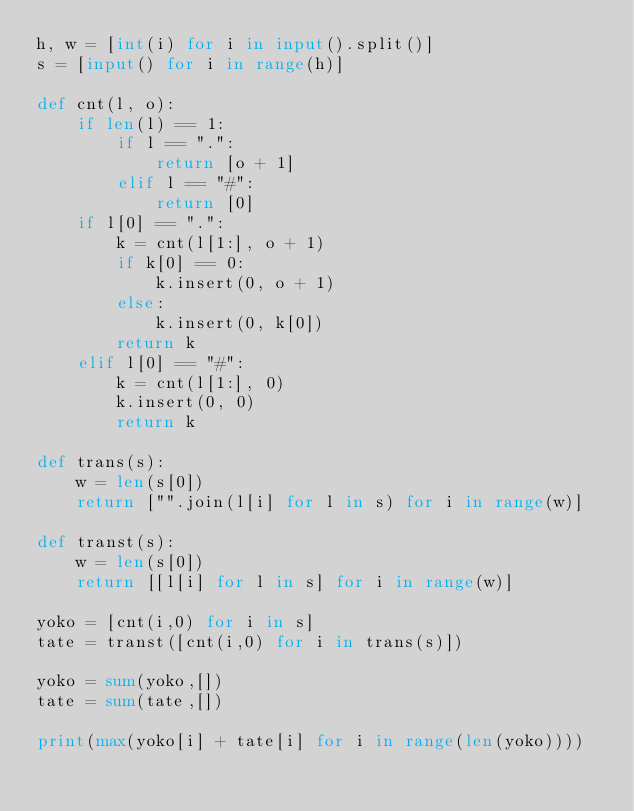Convert code to text. <code><loc_0><loc_0><loc_500><loc_500><_Python_>h, w = [int(i) for i in input().split()]
s = [input() for i in range(h)]

def cnt(l, o):
	if len(l) == 1:
		if l == ".":
			return [o + 1]
		elif l == "#":
			return [0]
	if l[0] == ".":
		k = cnt(l[1:], o + 1)
		if k[0] == 0:
			k.insert(0, o + 1)
		else:
			k.insert(0, k[0])
		return k
	elif l[0] == "#":
		k = cnt(l[1:], 0)
		k.insert(0, 0)
		return k

def trans(s):
	w = len(s[0])
	return ["".join(l[i] for l in s) for i in range(w)]
	
def transt(s):
	w = len(s[0])
	return [[l[i] for l in s] for i in range(w)]
			
yoko = [cnt(i,0) for i in s]
tate = transt([cnt(i,0) for i in trans(s)])

yoko = sum(yoko,[])
tate = sum(tate,[])

print(max(yoko[i] + tate[i] for i in range(len(yoko))))
</code> 